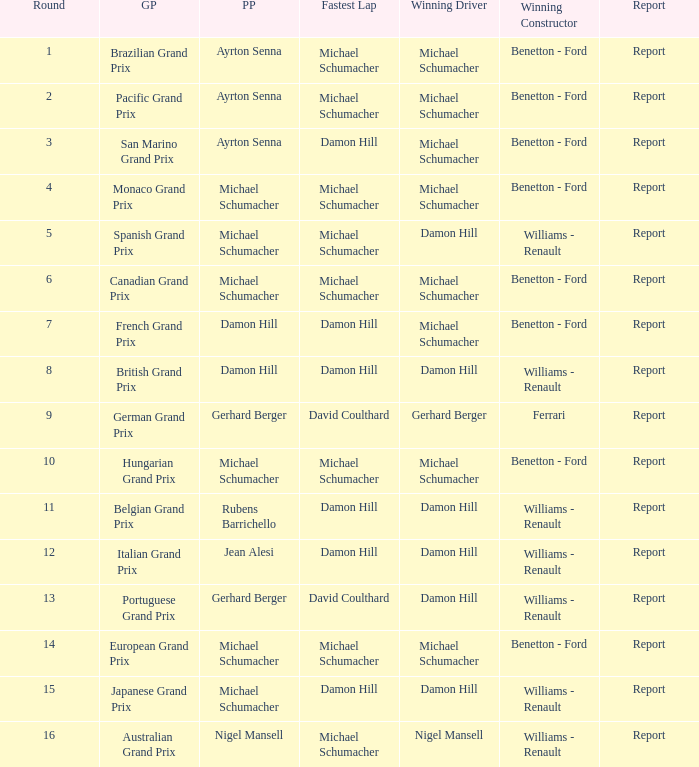Name the pole position at the japanese grand prix when the fastest lap is damon hill Michael Schumacher. 